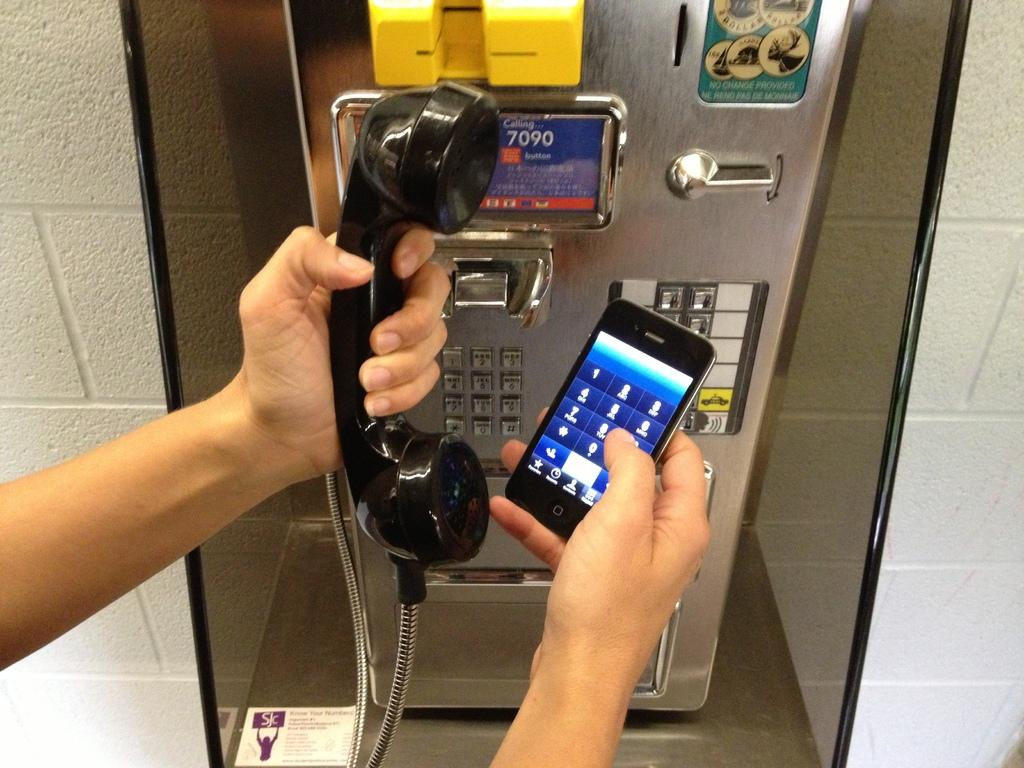What electronic devices are visible in the image? There is a telephone and a mobile in the image. Who is holding the electronic devices in the image? A human is holding the telephone and mobile in the image. What can be seen in the background of the image? There is a wall in the background of the image. How many balls are being juggled by the snake in the image? There is no snake or balls present in the image. 